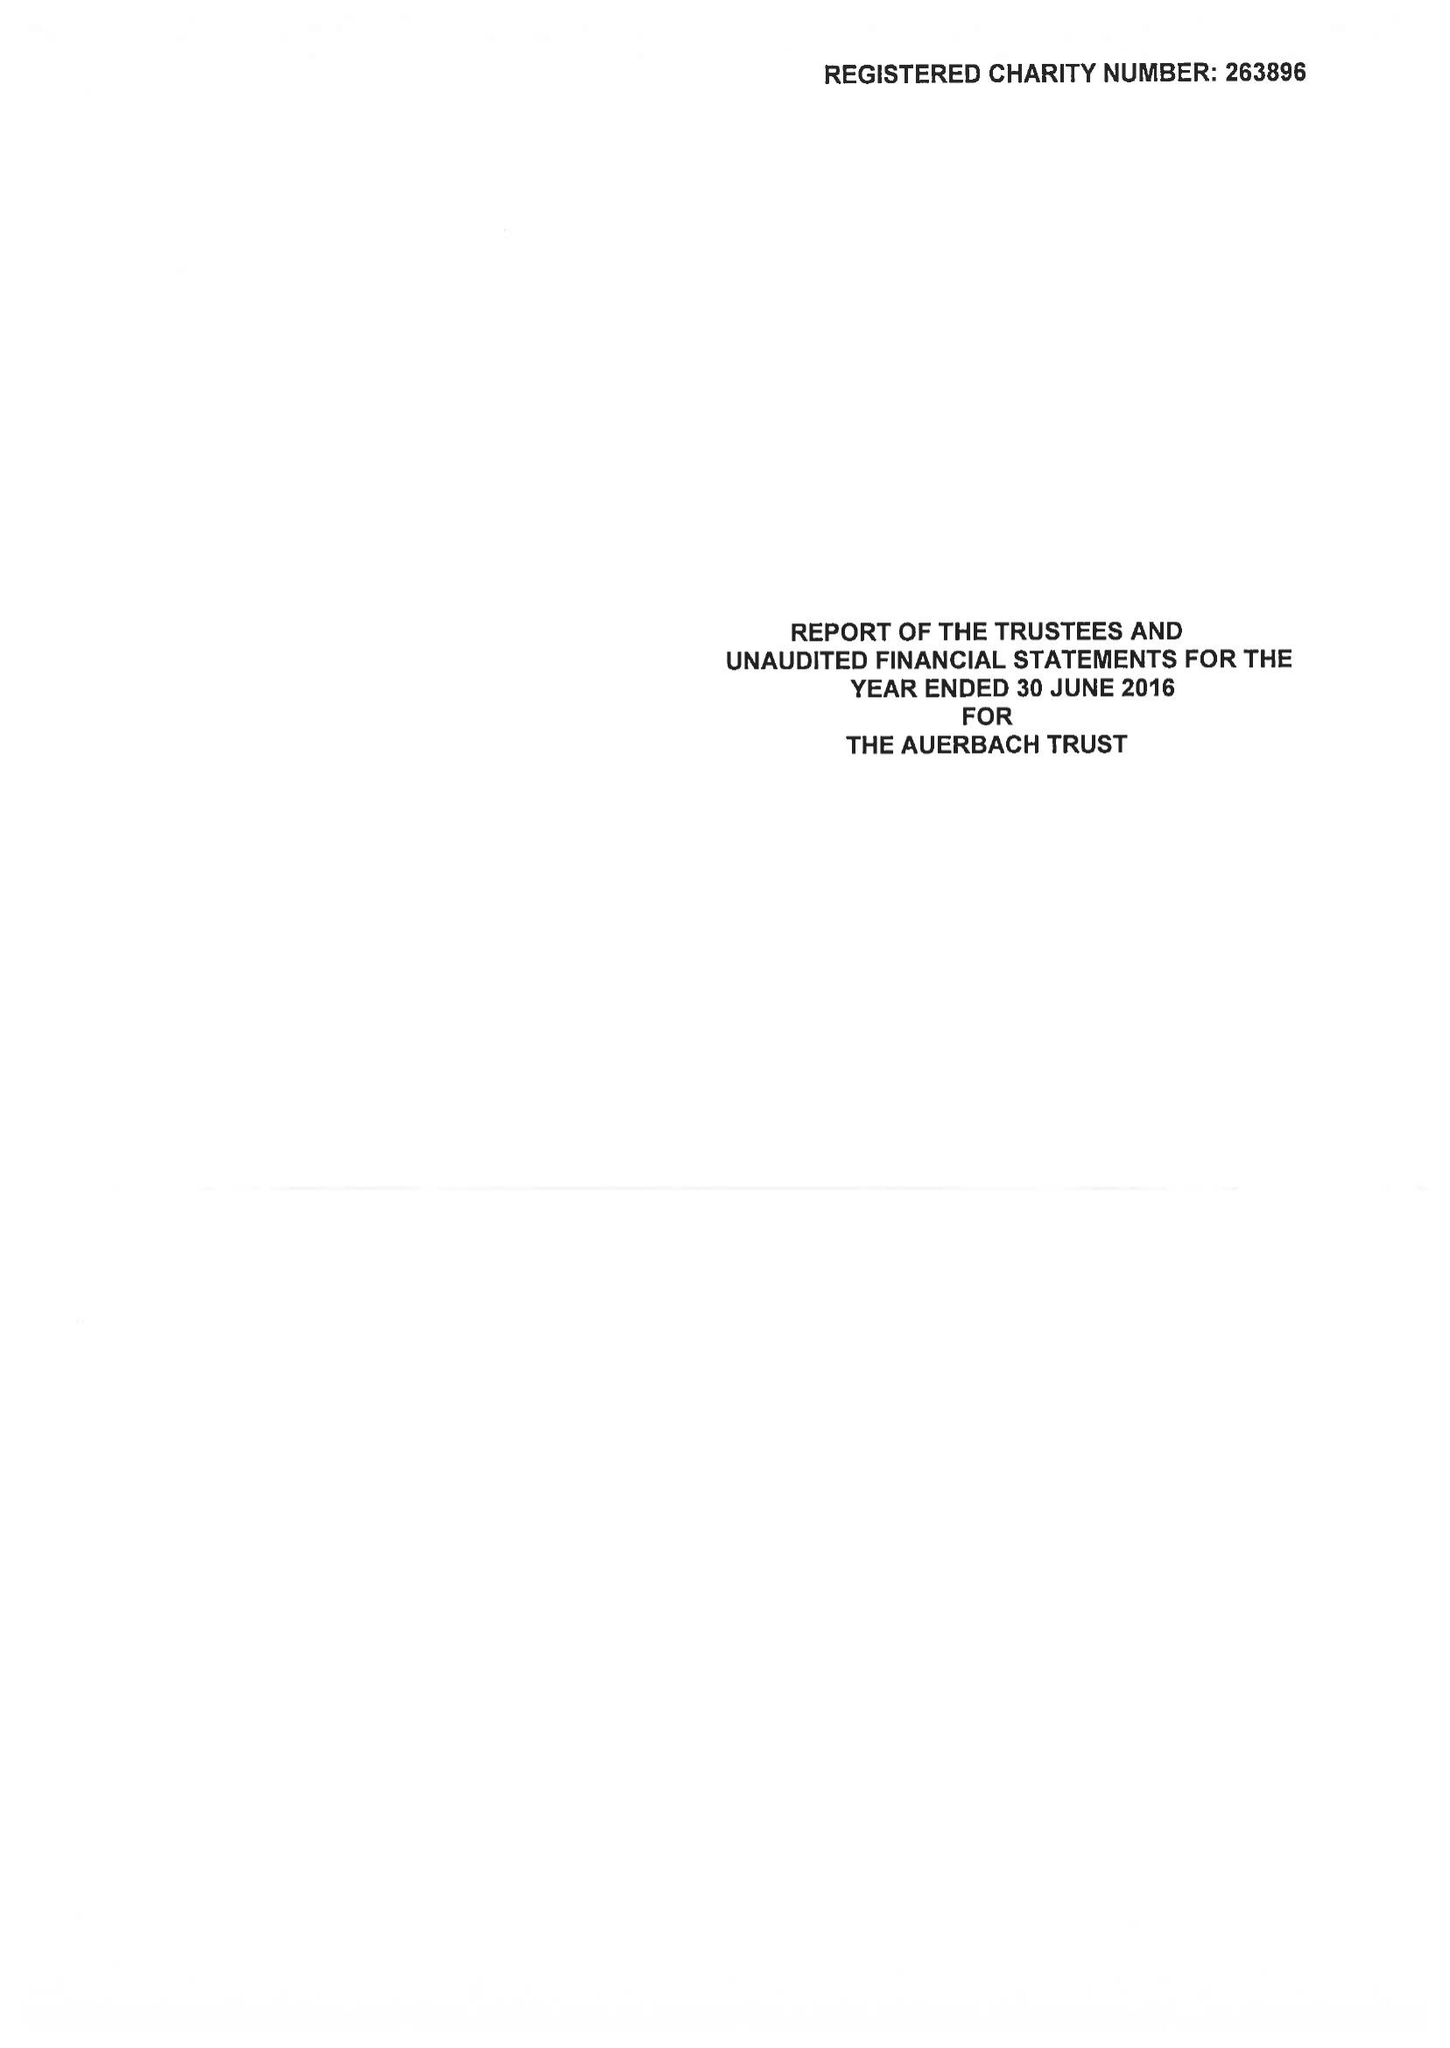What is the value for the address__post_town?
Answer the question using a single word or phrase. LONDON 